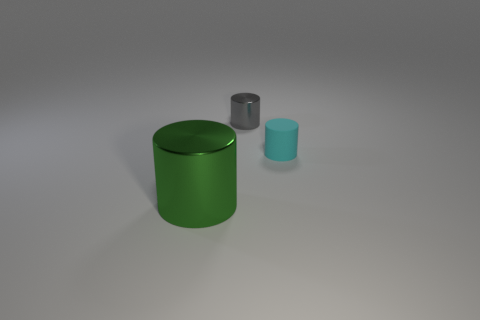What could be the function of these objects? While their exact function is not clear without more context, these cylindrical objects might serve as containers, stands, or simple geometric models used for visual or design purposes. 